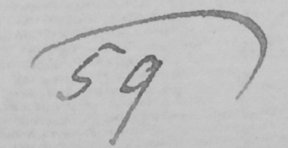Transcribe the text shown in this historical manuscript line. 59 ) 